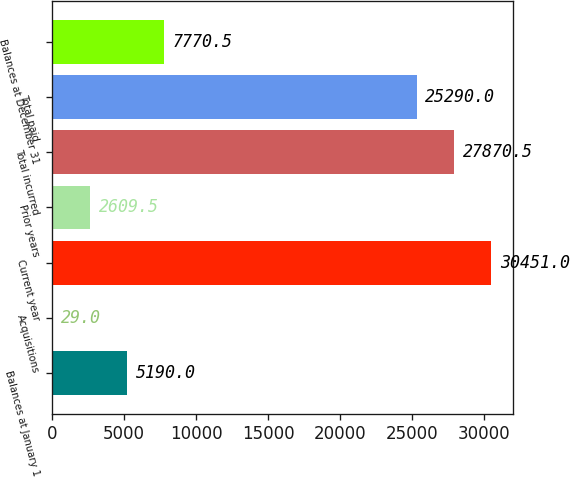<chart> <loc_0><loc_0><loc_500><loc_500><bar_chart><fcel>Balances at January 1<fcel>Acquisitions<fcel>Current year<fcel>Prior years<fcel>Total incurred<fcel>Total paid<fcel>Balances at December 31<nl><fcel>5190<fcel>29<fcel>30451<fcel>2609.5<fcel>27870.5<fcel>25290<fcel>7770.5<nl></chart> 